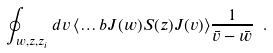Convert formula to latex. <formula><loc_0><loc_0><loc_500><loc_500>\oint _ { w , z , z _ { i } } d v \, \langle \dots b J ( w ) S ( z ) J ( v ) \rangle \frac { 1 } { \bar { v } - \bar { w } } \ .</formula> 